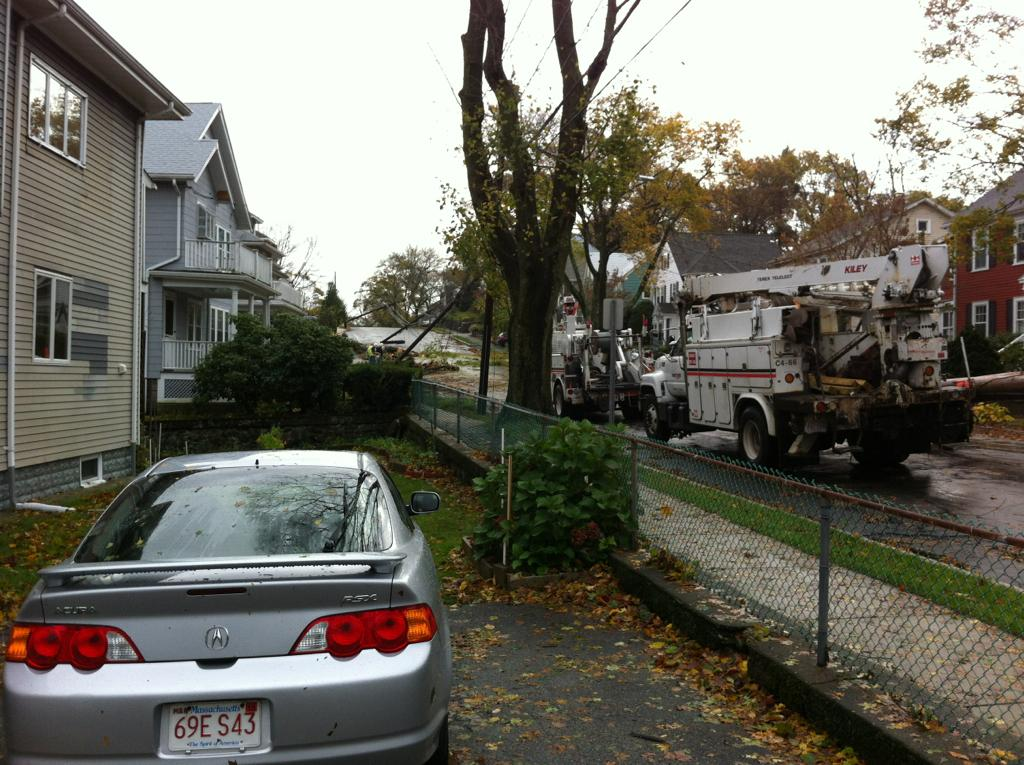What types of objects can be seen in the image? There are vehicles, trees, plants, houses, wires, and dried leaves visible in the image. Can you describe the setting of the image? The image shows vehicles on a street, with trees, plants, and houses in the background. The sky is visible at the top of the image, and wires are present. Dried leaves are visible at the bottom of the image. What type of jelly is being served on the plate in the image? There is no plate or jelly present in the image. How many potatoes can be seen in the image? There are no potatoes visible in the image. 